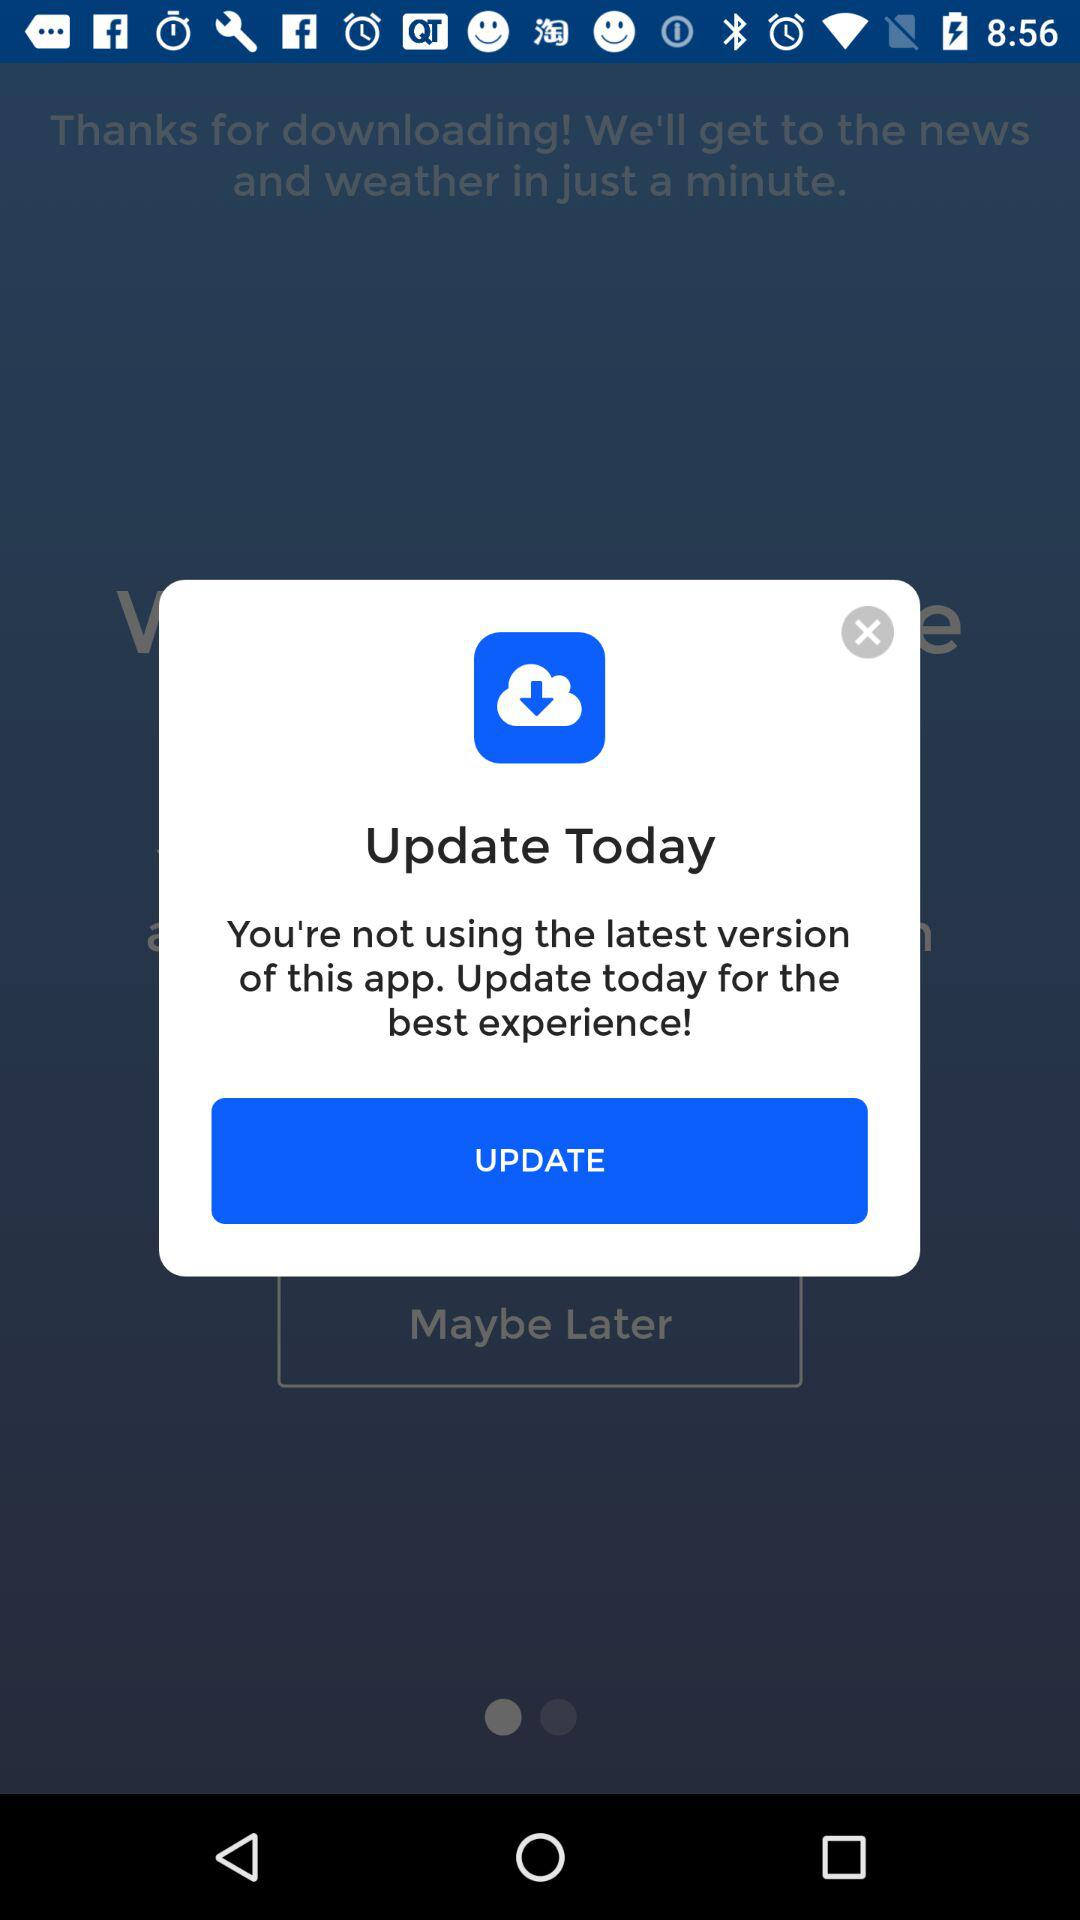What is the alert? The alert is "You're not using the latest version of this app. Update today for the best experience!". 